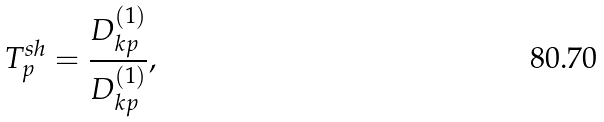Convert formula to latex. <formula><loc_0><loc_0><loc_500><loc_500>T _ { p } ^ { s h } = \frac { D _ { k p } ^ { ( 1 ) } } { D _ { k p } ^ { ( 1 ) } } ,</formula> 